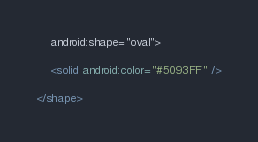<code> <loc_0><loc_0><loc_500><loc_500><_XML_>	android:shape="oval">

	<solid android:color="#5093FF" />

</shape></code> 